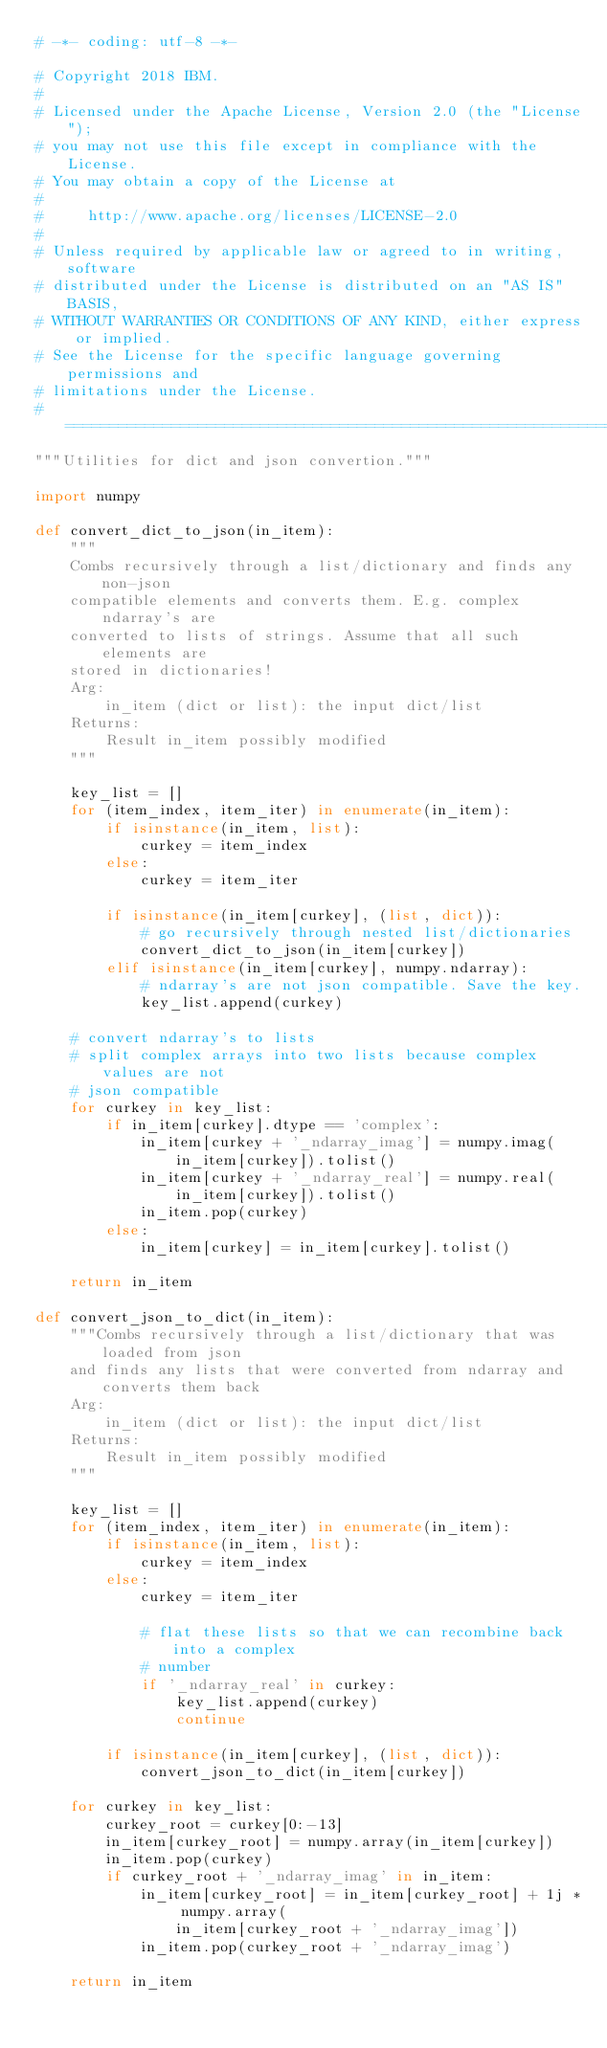Convert code to text. <code><loc_0><loc_0><loc_500><loc_500><_Python_># -*- coding: utf-8 -*-

# Copyright 2018 IBM.
#
# Licensed under the Apache License, Version 2.0 (the "License");
# you may not use this file except in compliance with the License.
# You may obtain a copy of the License at
#
#     http://www.apache.org/licenses/LICENSE-2.0
#
# Unless required by applicable law or agreed to in writing, software
# distributed under the License is distributed on an "AS IS" BASIS,
# WITHOUT WARRANTIES OR CONDITIONS OF ANY KIND, either express or implied.
# See the License for the specific language governing permissions and
# limitations under the License.
# =============================================================================
"""Utilities for dict and json convertion."""

import numpy

def convert_dict_to_json(in_item):
    """
    Combs recursively through a list/dictionary and finds any non-json
    compatible elements and converts them. E.g. complex ndarray's are
    converted to lists of strings. Assume that all such elements are
    stored in dictionaries!
    Arg:
        in_item (dict or list): the input dict/list
    Returns:
        Result in_item possibly modified
    """

    key_list = []
    for (item_index, item_iter) in enumerate(in_item):
        if isinstance(in_item, list):
            curkey = item_index
        else:
            curkey = item_iter

        if isinstance(in_item[curkey], (list, dict)):
            # go recursively through nested list/dictionaries
            convert_dict_to_json(in_item[curkey])
        elif isinstance(in_item[curkey], numpy.ndarray):
            # ndarray's are not json compatible. Save the key.
            key_list.append(curkey)

    # convert ndarray's to lists
    # split complex arrays into two lists because complex values are not
    # json compatible
    for curkey in key_list:
        if in_item[curkey].dtype == 'complex':
            in_item[curkey + '_ndarray_imag'] = numpy.imag(
                in_item[curkey]).tolist()
            in_item[curkey + '_ndarray_real'] = numpy.real(
                in_item[curkey]).tolist()
            in_item.pop(curkey)
        else:
            in_item[curkey] = in_item[curkey].tolist()
            
    return in_item
            
def convert_json_to_dict(in_item):
    """Combs recursively through a list/dictionary that was loaded from json
    and finds any lists that were converted from ndarray and converts them back
    Arg:
        in_item (dict or list): the input dict/list
    Returns:
        Result in_item possibly modified
    """

    key_list = []
    for (item_index, item_iter) in enumerate(in_item):
        if isinstance(in_item, list):
            curkey = item_index
        else:
            curkey = item_iter

            # flat these lists so that we can recombine back into a complex
            # number
            if '_ndarray_real' in curkey:
                key_list.append(curkey)
                continue

        if isinstance(in_item[curkey], (list, dict)):
            convert_json_to_dict(in_item[curkey])

    for curkey in key_list:
        curkey_root = curkey[0:-13]
        in_item[curkey_root] = numpy.array(in_item[curkey])
        in_item.pop(curkey)
        if curkey_root + '_ndarray_imag' in in_item:
            in_item[curkey_root] = in_item[curkey_root] + 1j * numpy.array(
                in_item[curkey_root + '_ndarray_imag'])
            in_item.pop(curkey_root + '_ndarray_imag')
            
    return in_item

</code> 